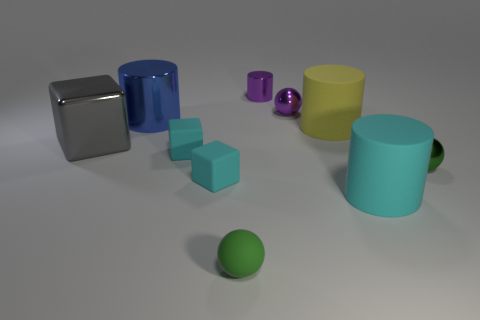There is a big thing that is the same material as the big blue cylinder; what shape is it?
Offer a terse response. Cube. What size is the cyan rubber object that is on the right side of the shiny cylinder that is on the right side of the rubber sphere?
Provide a succinct answer. Large. How many big things are purple metallic cylinders or rubber cylinders?
Your response must be concise. 2. What number of other things are the same color as the metal cube?
Make the answer very short. 0. Does the metal cylinder that is behind the blue object have the same size as the ball that is behind the yellow thing?
Your answer should be compact. Yes. Do the blue object and the thing that is on the right side of the cyan matte cylinder have the same material?
Your response must be concise. Yes. Are there more cyan matte cubes that are to the right of the purple shiny cylinder than small green shiny spheres behind the large cyan object?
Keep it short and to the point. No. What color is the metallic sphere left of the cyan thing that is to the right of the green matte object?
Provide a succinct answer. Purple. How many spheres are either big metal objects or large yellow things?
Make the answer very short. 0. How many small spheres are behind the large metallic cube and in front of the cyan cylinder?
Offer a terse response. 0. 